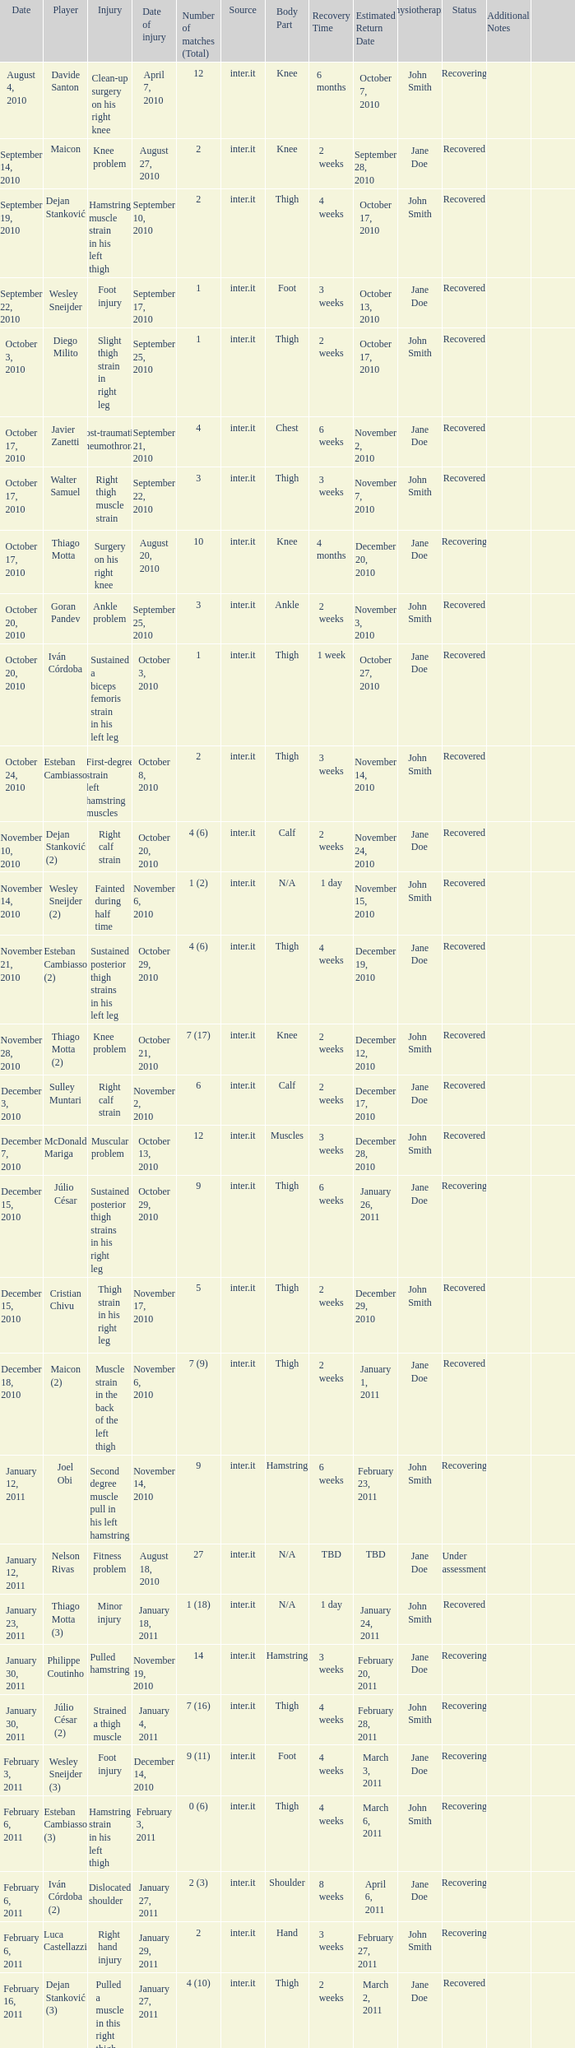What is the date of injury for player Wesley sneijder (2)? November 6, 2010. 